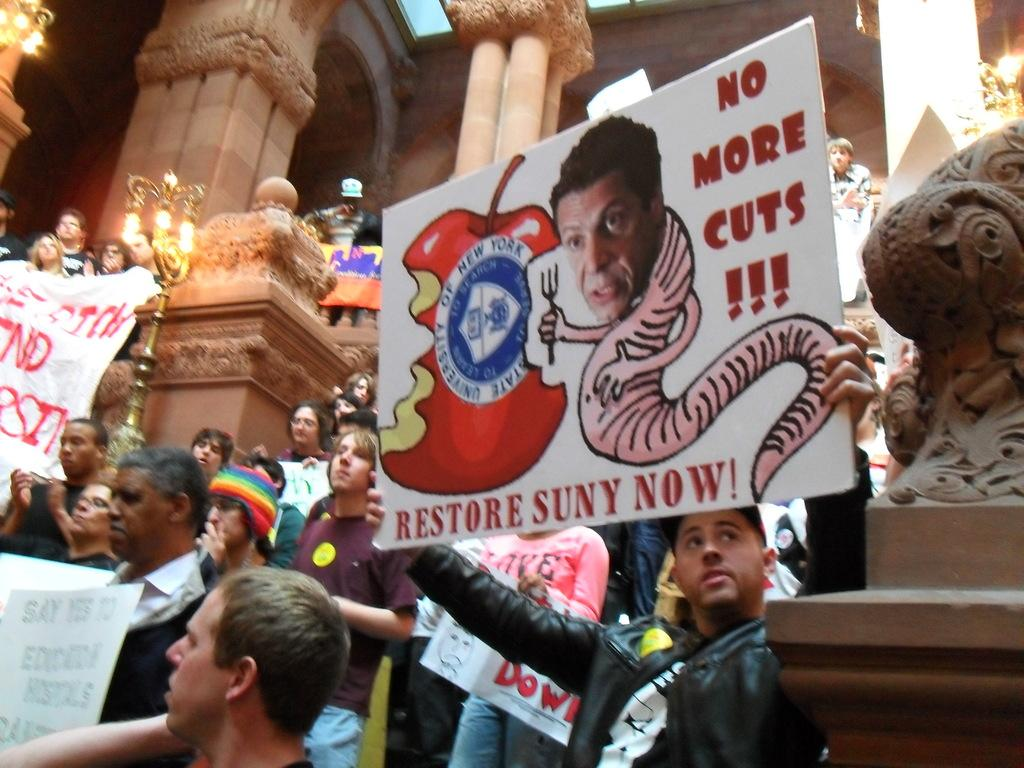What are the people in the image holding? The people in the image are holding boards with text and images. What can be seen illuminating the scene in the image? There are lights visible in the image. What architectural features are present in the image? There are pillars in the image. Can you see any seashore or ships in the image? No, there is no seashore or ship visible in the image. What type of shoes are the people wearing in the image? The image does not show the people's shoes, so it cannot be determined from the image. 